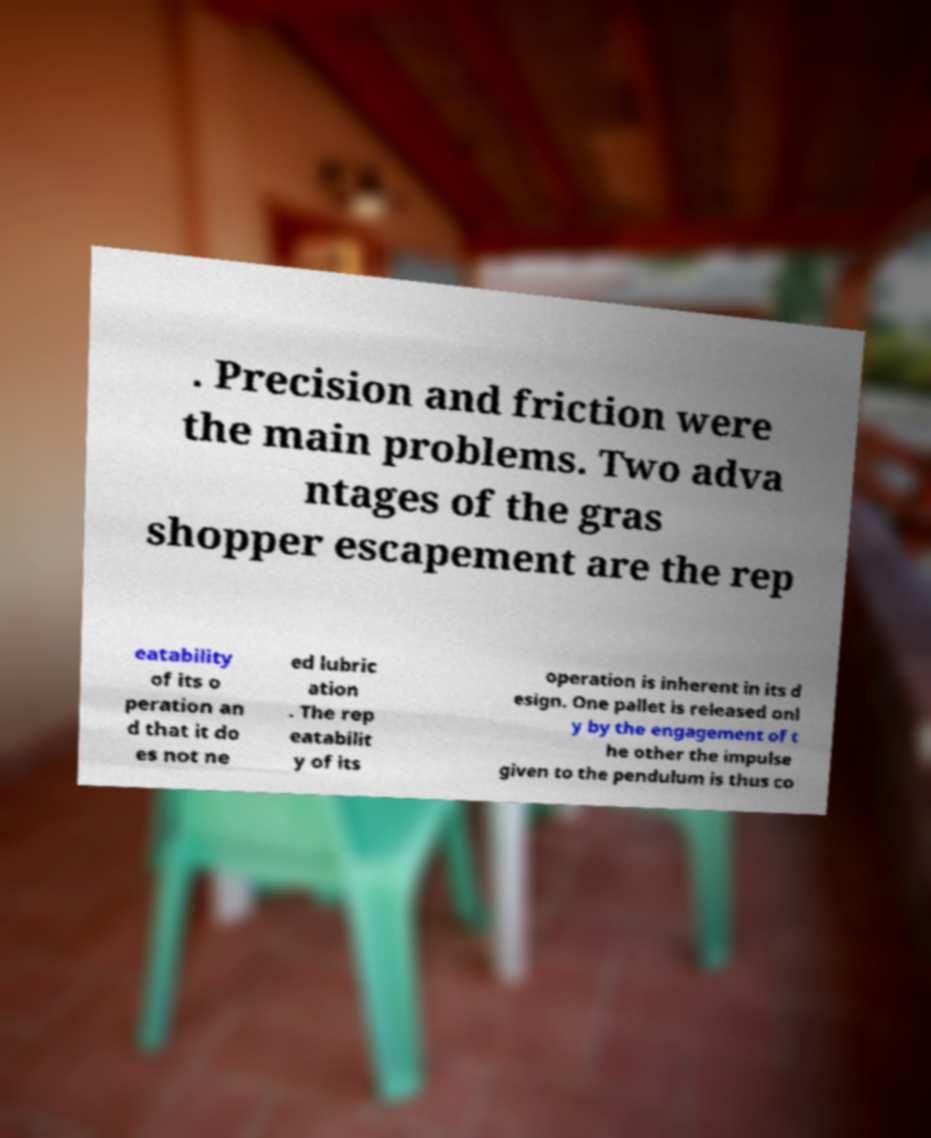Please read and relay the text visible in this image. What does it say? . Precision and friction were the main problems. Two adva ntages of the gras shopper escapement are the rep eatability of its o peration an d that it do es not ne ed lubric ation . The rep eatabilit y of its operation is inherent in its d esign. One pallet is released onl y by the engagement of t he other the impulse given to the pendulum is thus co 